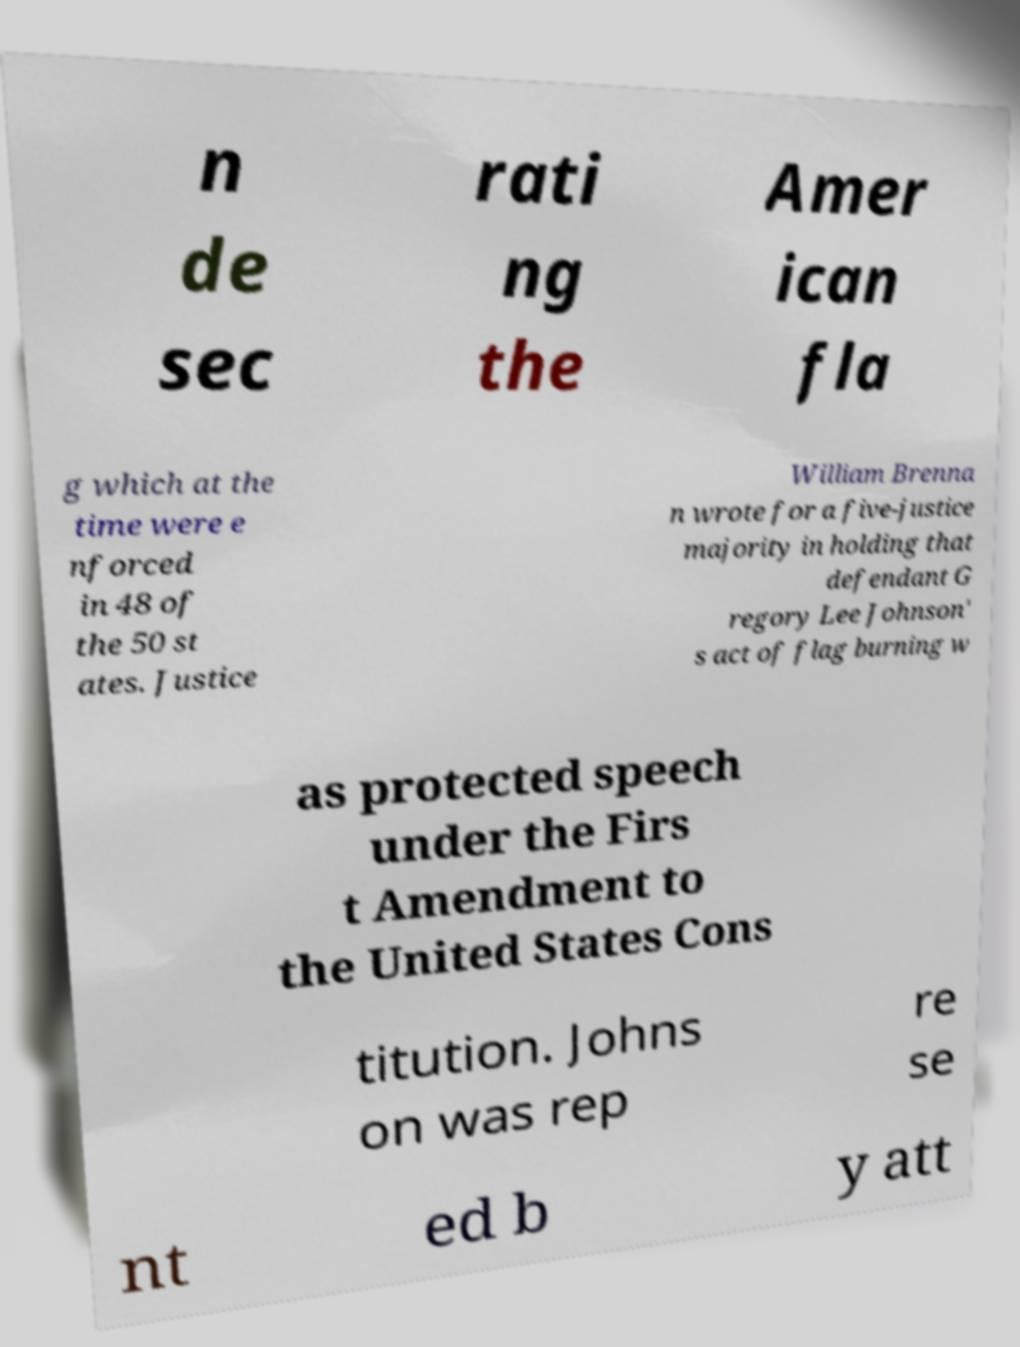Please identify and transcribe the text found in this image. n de sec rati ng the Amer ican fla g which at the time were e nforced in 48 of the 50 st ates. Justice William Brenna n wrote for a five-justice majority in holding that defendant G regory Lee Johnson' s act of flag burning w as protected speech under the Firs t Amendment to the United States Cons titution. Johns on was rep re se nt ed b y att 